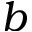<formula> <loc_0><loc_0><loc_500><loc_500>b</formula> 